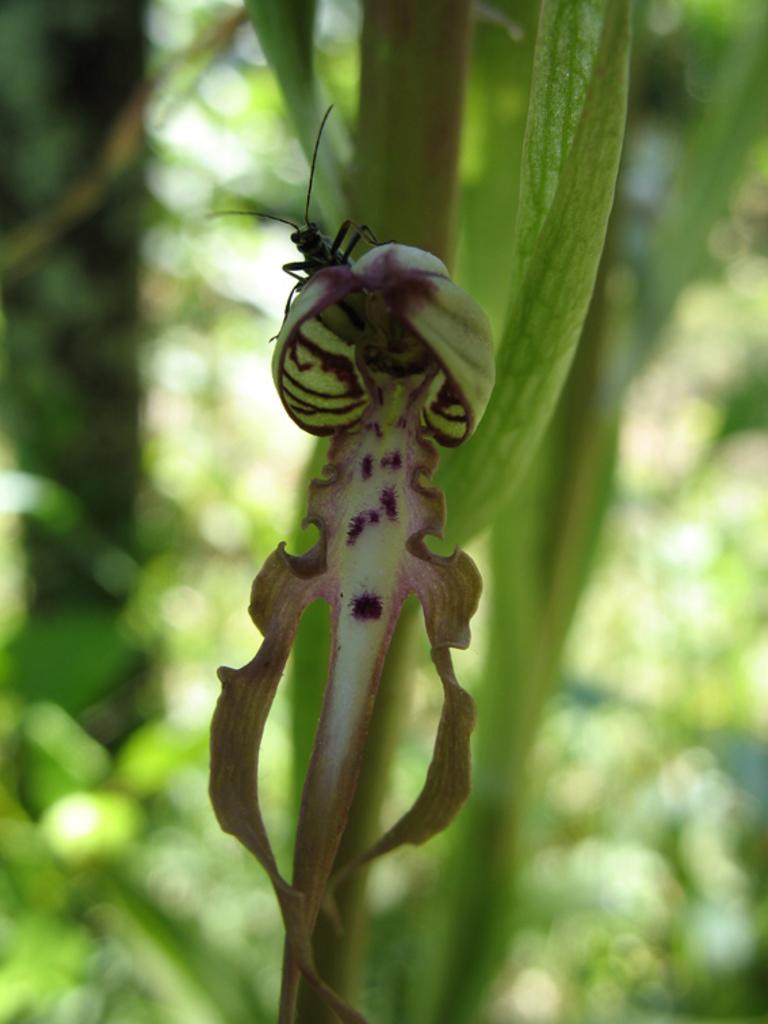Please provide a concise description of this image. In this picture we can see a leaf, on the leaf we can see some insect. 